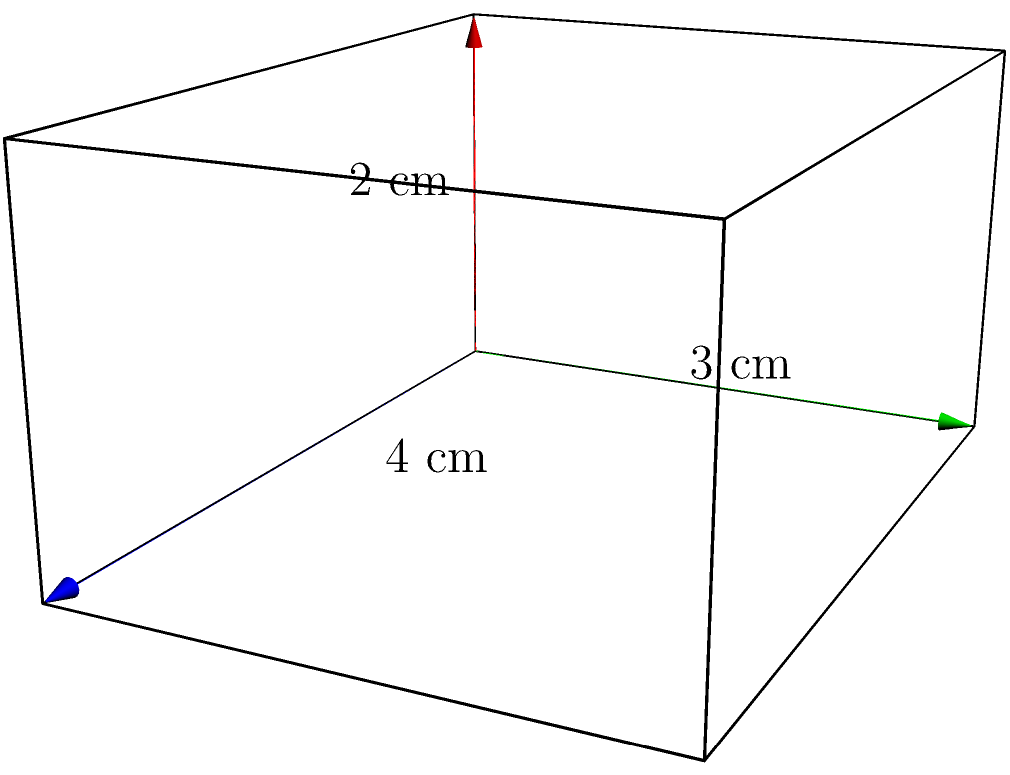As a bookseller, you're organizing a display for a new collection of miniature books. You want to create a custom acrylic case to showcase these books. The case needs to be in the shape of a rectangular prism with dimensions 4 cm x 3 cm x 2 cm, as shown in the diagram. Calculate the total surface area of this acrylic case to determine how much material you'll need to order. Round your answer to the nearest square centimeter. To find the surface area of a rectangular prism, we need to calculate the area of each face and sum them up. Let's break it down step-by-step:

1. Identify the dimensions:
   Length (l) = 4 cm
   Width (w) = 3 cm
   Height (h) = 2 cm

2. Calculate the area of each face:
   - Front and back faces: $l * h = 4 * 2 = 8$ cm²
   - Top and bottom faces: $l * w = 4 * 3 = 12$ cm²
   - Left and right faces: $w * h = 3 * 2 = 6$ cm²

3. Multiply each face area by 2 (as there are two of each):
   - Front and back: $8 * 2 = 16$ cm²
   - Top and bottom: $12 * 2 = 24$ cm²
   - Left and right: $6 * 2 = 12$ cm²

4. Sum up all the areas:
   Total surface area = $16 + 24 + 12 = 52$ cm²

5. Round to the nearest square centimeter:
   52 cm² is already a whole number, so no rounding is necessary.

Therefore, the total surface area of the acrylic case is 52 square centimeters.
Answer: 52 cm² 